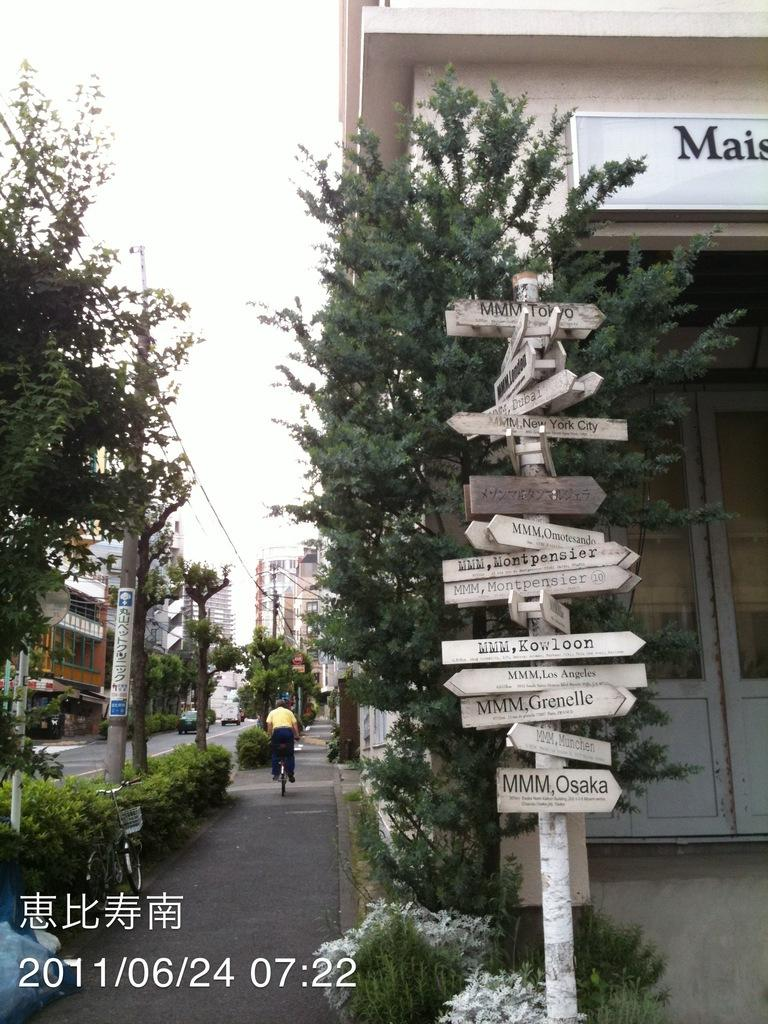What is attached to the pole in the image? There are sign boards attached to the pole in the image. What is the person in the image doing? The person is riding a bicycle on the road. What can be seen in the sky in the image? The sky is visible in the image. What type of vegetation is present in the image? There are trees and bushes visible in the image. What type of structures are present in the image? Buildings are present in the image. Are there any other poles visible in the image? Yes, street poles are present in the image. Where is the maid dusting the desk in the image? There is no desk or maid present in the image. What type of stick is the person holding while riding the bicycle in the image? The person riding the bicycle in the image is not holding any stick. 